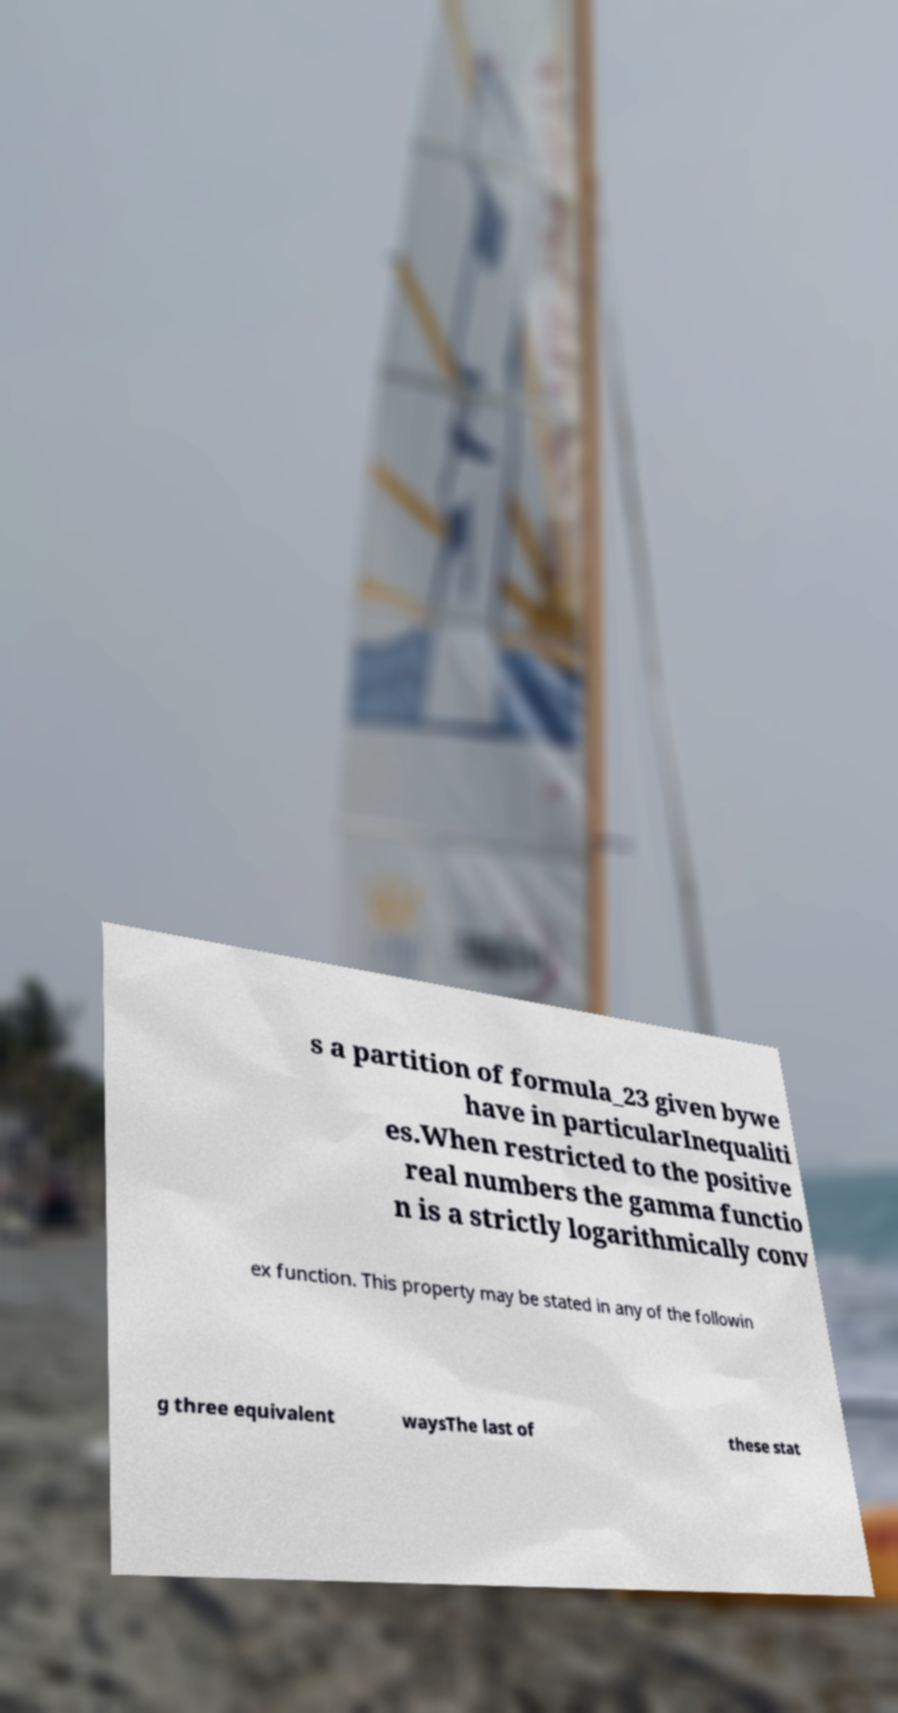Can you accurately transcribe the text from the provided image for me? s a partition of formula_23 given bywe have in particularInequaliti es.When restricted to the positive real numbers the gamma functio n is a strictly logarithmically conv ex function. This property may be stated in any of the followin g three equivalent waysThe last of these stat 